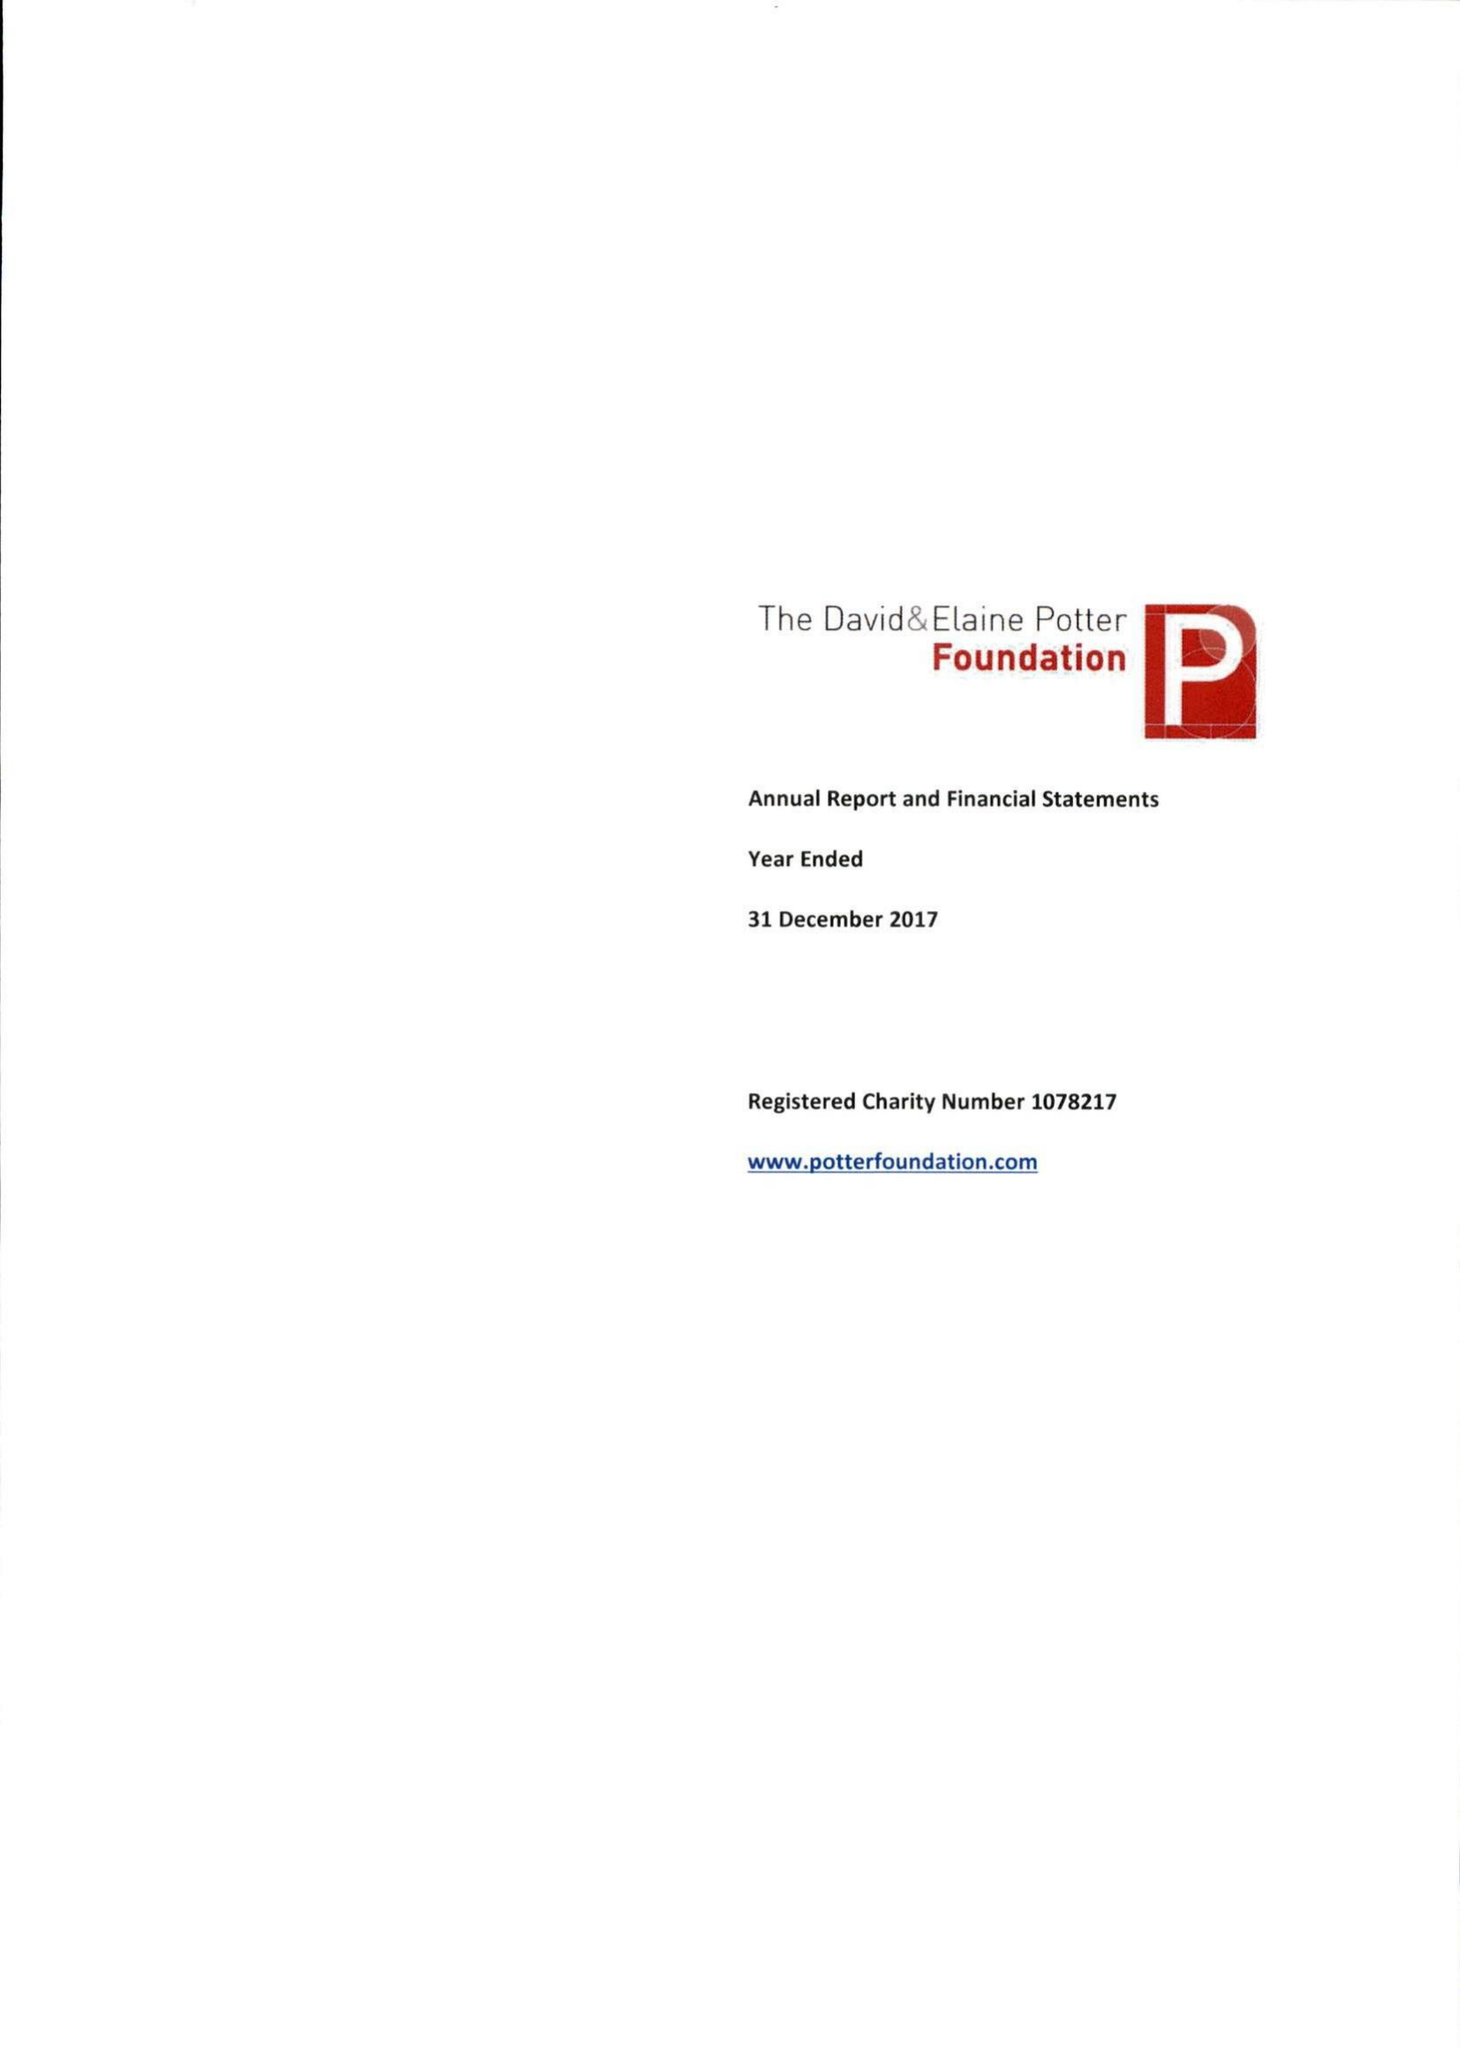What is the value for the address__postcode?
Answer the question using a single word or phrase. W1G 9YQ 